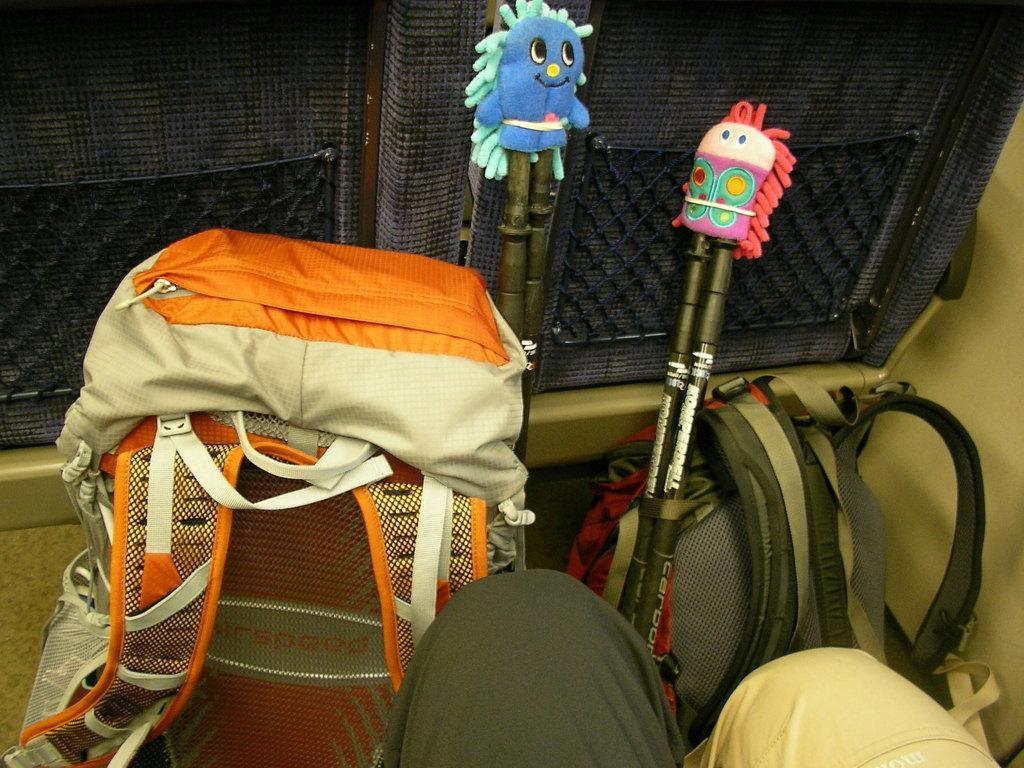Describe this image in one or two sentences. There are 2 bags and 2 pair of sticks here. 